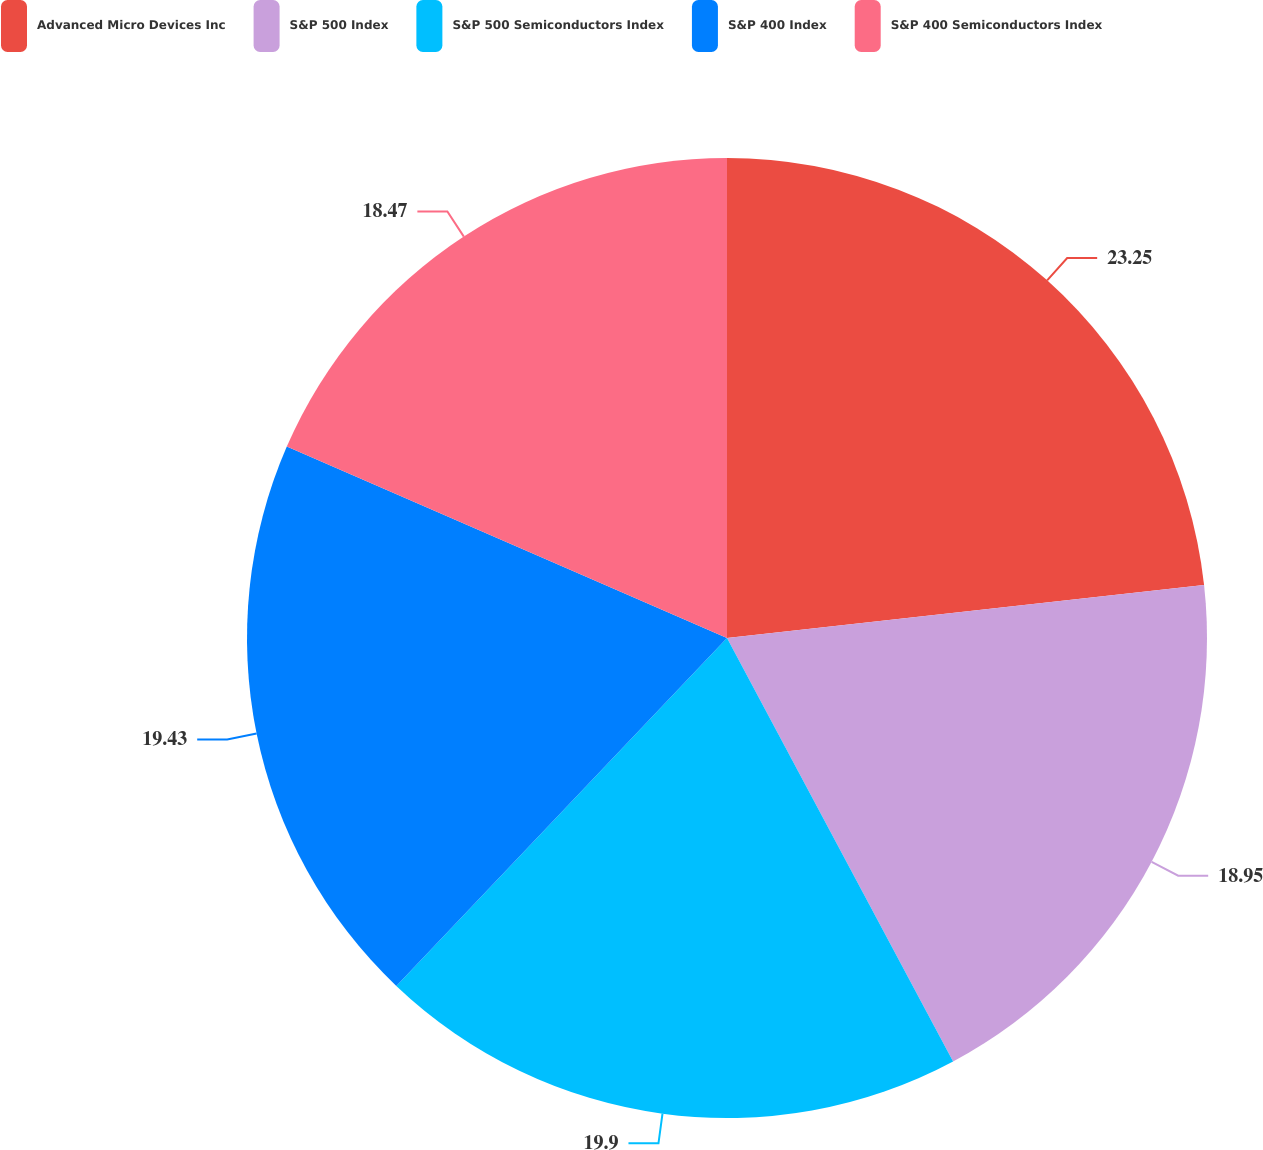<chart> <loc_0><loc_0><loc_500><loc_500><pie_chart><fcel>Advanced Micro Devices Inc<fcel>S&P 500 Index<fcel>S&P 500 Semiconductors Index<fcel>S&P 400 Index<fcel>S&P 400 Semiconductors Index<nl><fcel>23.24%<fcel>18.95%<fcel>19.9%<fcel>19.43%<fcel>18.47%<nl></chart> 